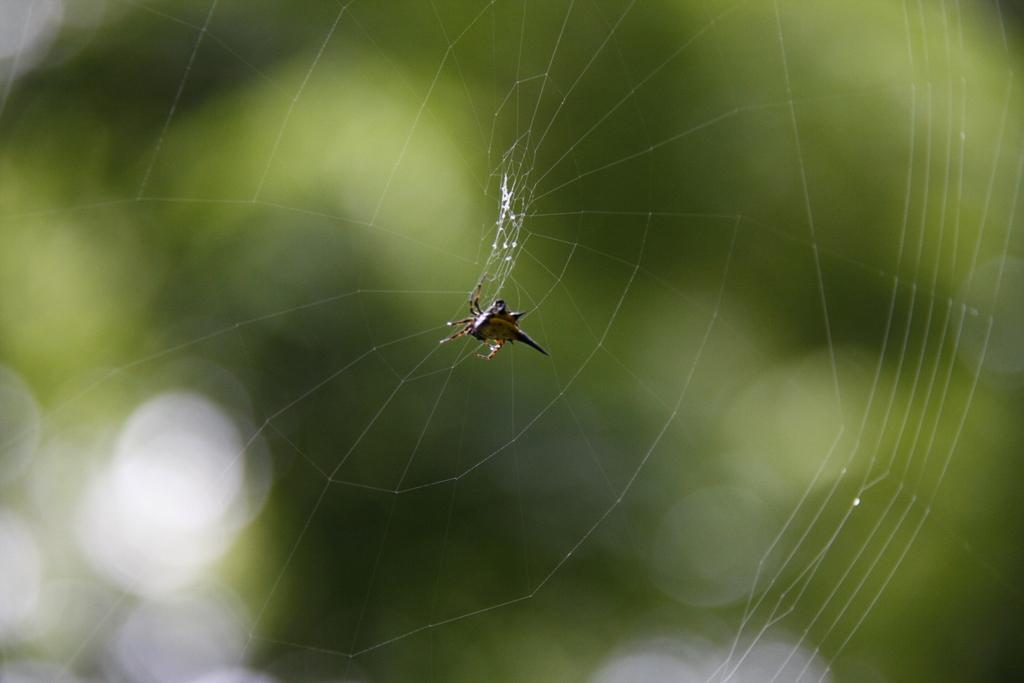What type of creature is present in the image? There is an insect in the image. Where is the insect located in the image? The insect is on a web. What color is the giraffe's front nail in the image? There is no giraffe or nail present in the image; it only features an insect on a web. 